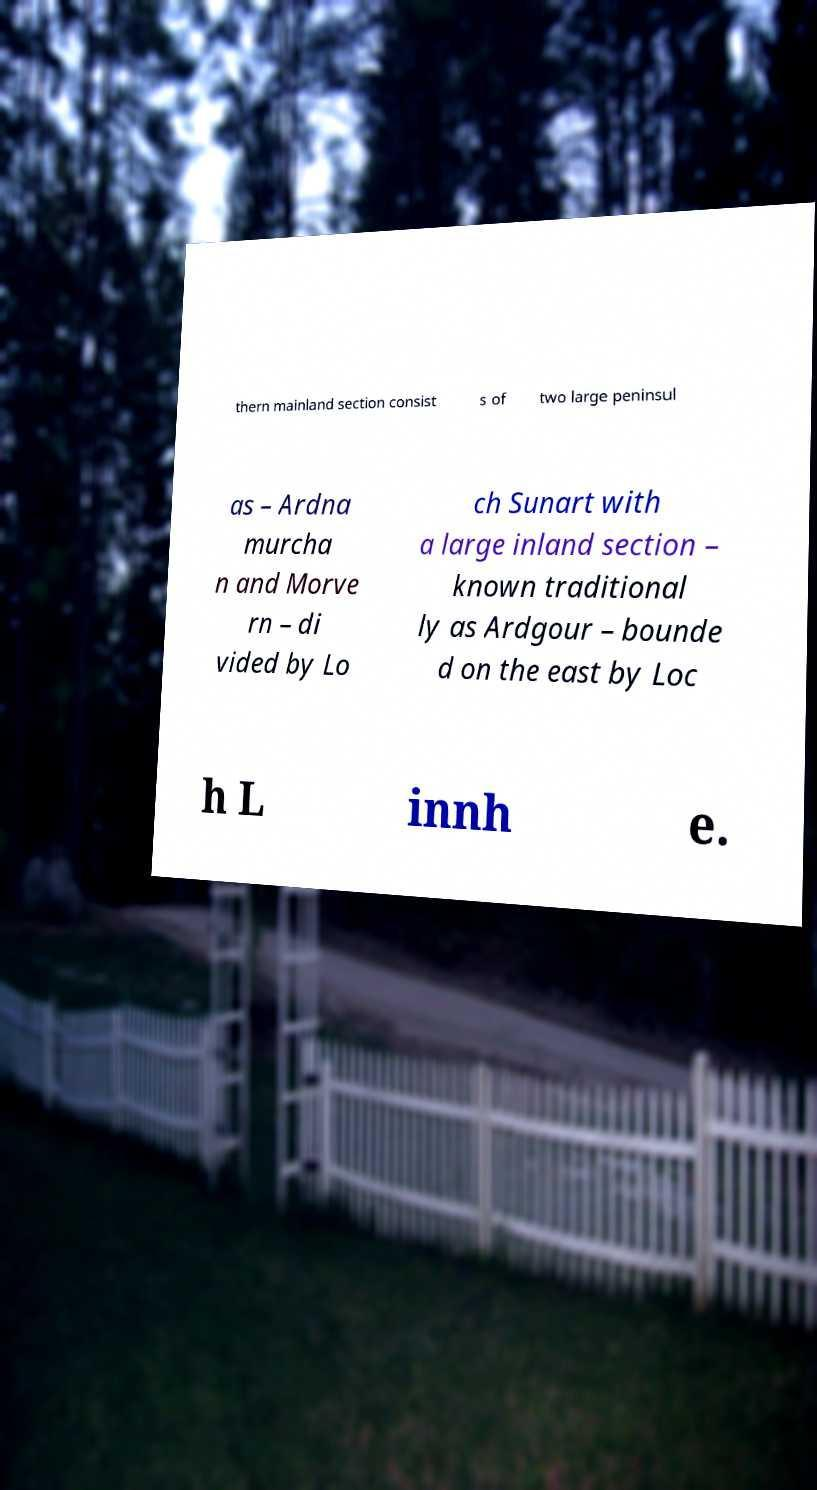Can you read and provide the text displayed in the image?This photo seems to have some interesting text. Can you extract and type it out for me? thern mainland section consist s of two large peninsul as – Ardna murcha n and Morve rn – di vided by Lo ch Sunart with a large inland section – known traditional ly as Ardgour – bounde d on the east by Loc h L innh e. 